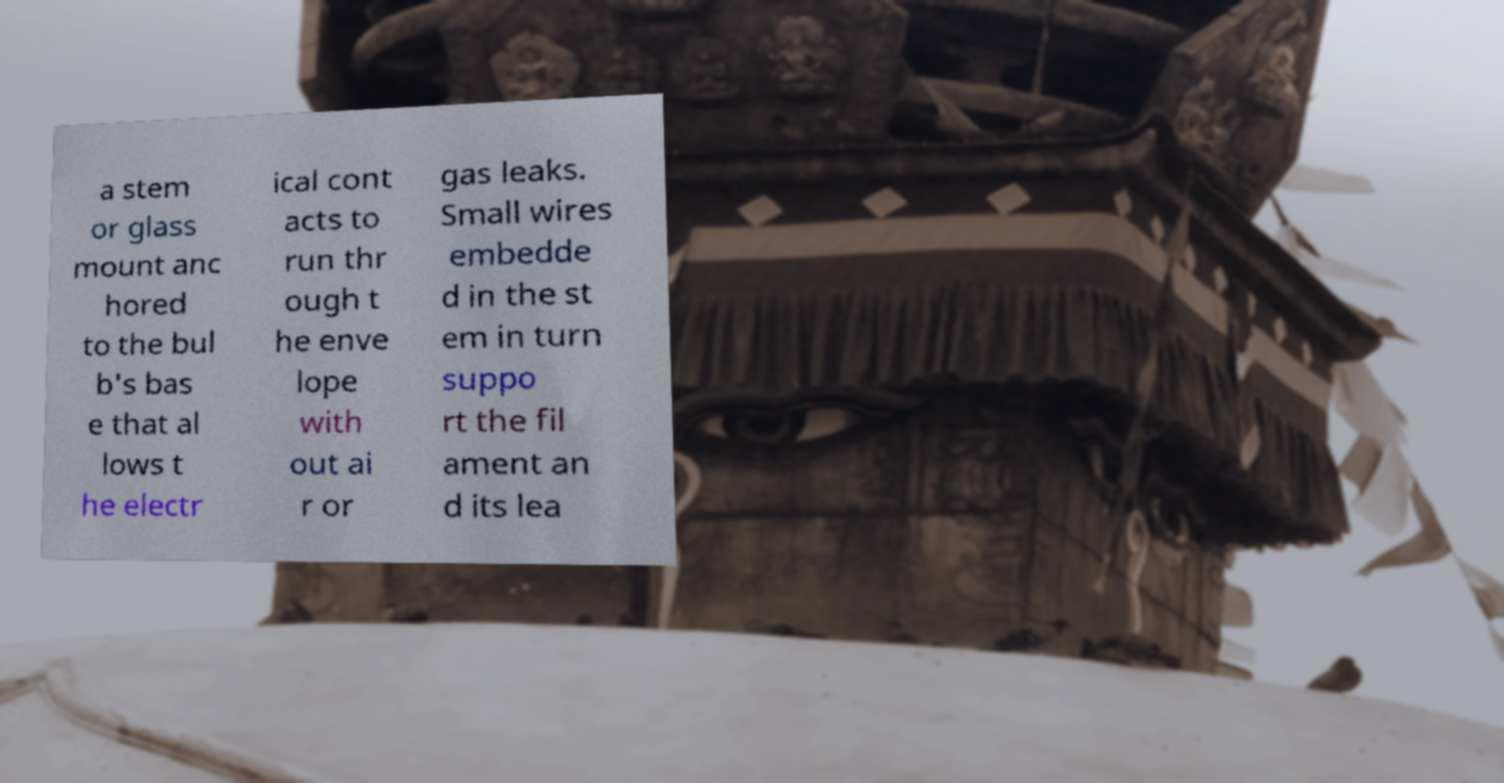Can you read and provide the text displayed in the image?This photo seems to have some interesting text. Can you extract and type it out for me? a stem or glass mount anc hored to the bul b's bas e that al lows t he electr ical cont acts to run thr ough t he enve lope with out ai r or gas leaks. Small wires embedde d in the st em in turn suppo rt the fil ament an d its lea 